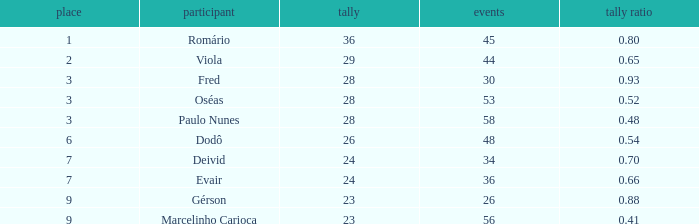How many goals hold a goal proportion under 1.0. 